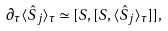Convert formula to latex. <formula><loc_0><loc_0><loc_500><loc_500>\partial _ { \tau } \langle \hat { S } _ { j } \rangle _ { \tau } \simeq [ { S } , [ { S } , \langle \hat { S } _ { j } \rangle _ { \tau } ] ] ,</formula> 